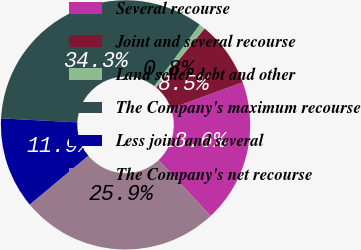Convert chart. <chart><loc_0><loc_0><loc_500><loc_500><pie_chart><fcel>Several recourse<fcel>Joint and several recourse<fcel>Land seller debt and other<fcel>The Company's maximum recourse<fcel>Less joint and several<fcel>The Company's net recourse<nl><fcel>18.58%<fcel>8.53%<fcel>0.8%<fcel>34.3%<fcel>11.88%<fcel>25.9%<nl></chart> 